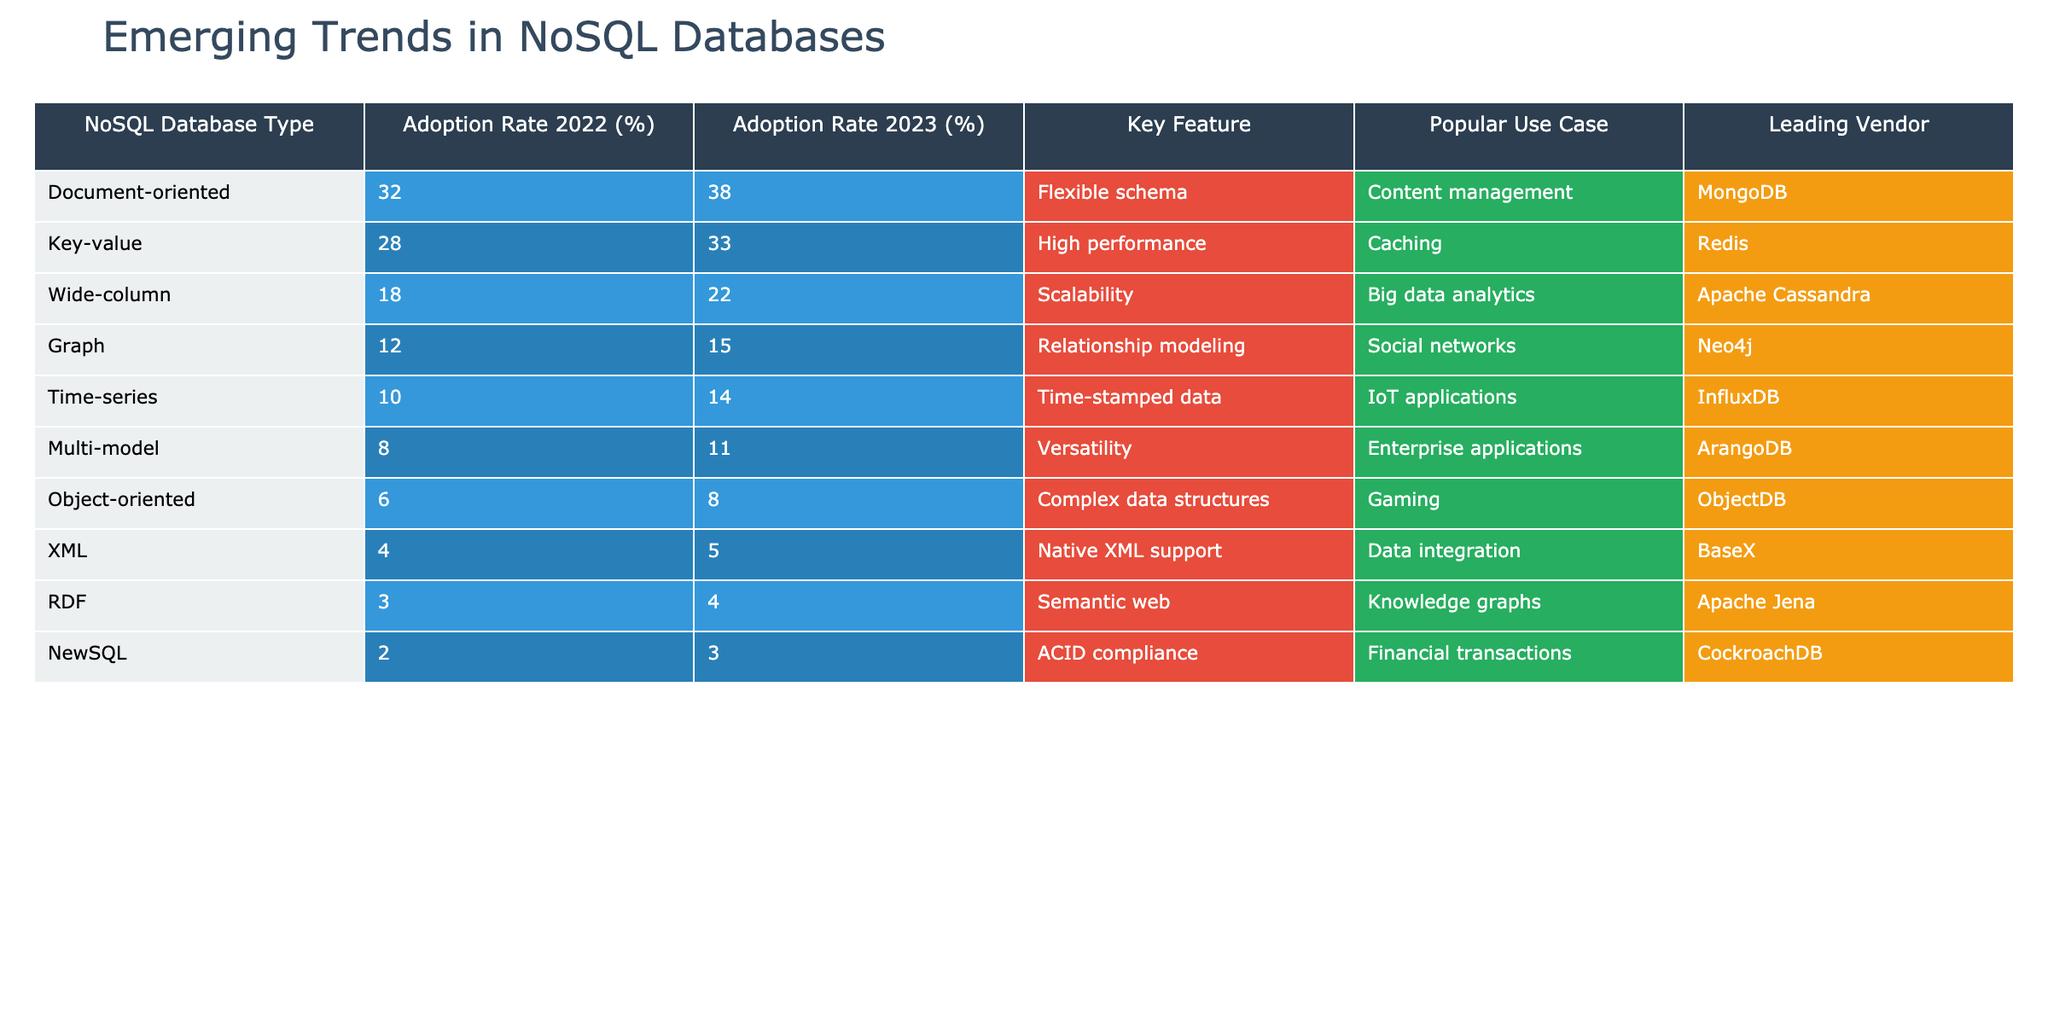What is the adoption rate of Document-oriented databases in 2023? The table shows that the adoption rate for Document-oriented databases in 2023 is 38%.
Answer: 38% Which NoSQL database type has the highest adoption rate in 2022? According to the table, Document-oriented databases have the highest adoption rate in 2022 at 32%.
Answer: Document-oriented What is the percentage increase in adoption rate for Time-series databases from 2022 to 2023? The adoption rate for Time-series databases increased from 10% in 2022 to 14% in 2023. The increase is 14% - 10% = 4%.
Answer: 4% Which NoSQL database type has the lowest adoption rate in 2023? In the table, RDF databases have the lowest adoption rate in 2023 at 4%.
Answer: RDF Is the adoption rate of NewSQL databases higher than 3% in 2023? The table indicates that the adoption rate of NewSQL databases in 2023 is 3%, which means the statement is false.
Answer: No What is the average adoption rate of the top three NoSQL database types in 2023 (Document-oriented, Key-value, and Wide-column)? The adoption rates of the top three types in 2023 are 38%, 33%, and 22%. Summing them gives 38 + 33 + 22 = 93%. Dividing by 3 for the average results in 93/3 = 31%.
Answer: 31% How much greater is the adoption rate of Key-value databases compared to Multi-model databases in 2023? The adoption rate of Key-value databases in 2023 is 33%, while for Multi-model databases, it is 11%. The difference is 33% - 11% = 22%.
Answer: 22% What is the leading vendor for Wide-column databases? According to the table, the leading vendor for Wide-column databases is Apache Cassandra.
Answer: Apache Cassandra Which type of NoSQL database has a key feature of ‘Relationship modeling’? The table states that the key feature of Graph databases is ‘Relationship modeling’.
Answer: Graph What trends can be observed in the adoption rates of NoSQL databases from 2022 to 2023? By examining the table, we see that most NoSQL databases have increased adoption rates, indicating a growing acceptance and usage of these technologies.
Answer: General growth Which NoSQL database type shows the largest percentage increase in adoption rate from 2022 to 2023? Comparing the percentage changes, Time-series databases show an increase of 4% (from 10% to 14%), which is the largest increase among the listed types.
Answer: Time-series 